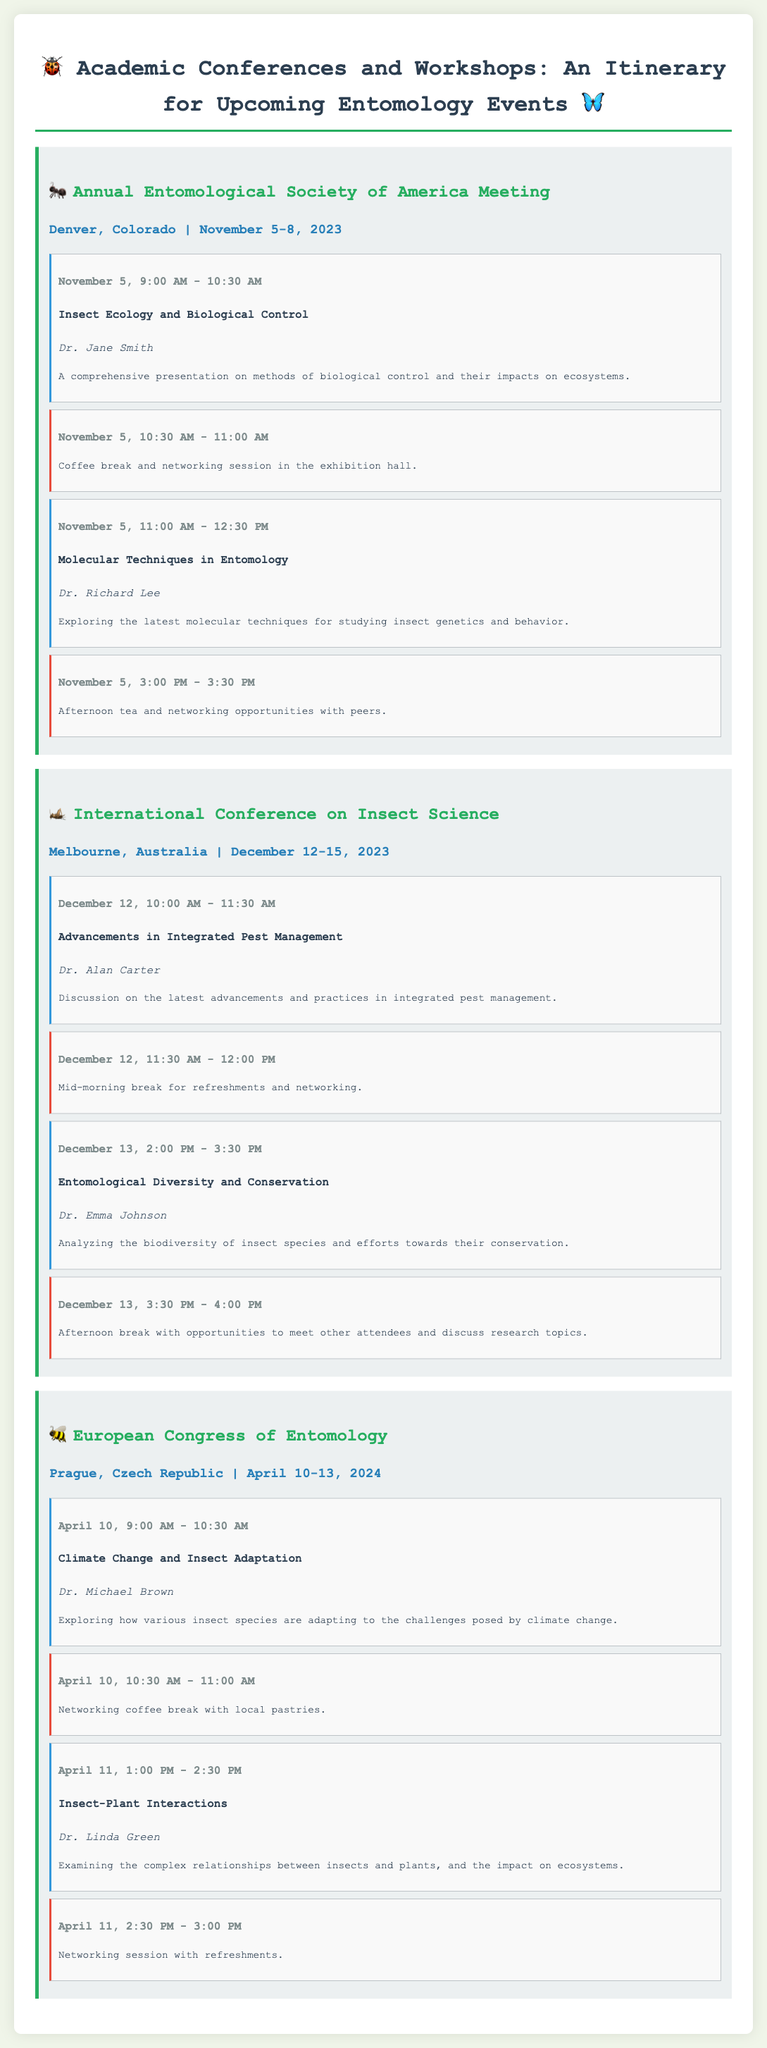what is the location of the Annual Entomological Society of America Meeting? The location is stated in the event header, which is Denver, Colorado.
Answer: Denver, Colorado who is presenting on Insect Ecology and Biological Control? The presenter's name is provided in the presentation section for the topic.
Answer: Dr. Jane Smith what date does the International Conference on Insect Science start? The start date is clearly stated in the event header.
Answer: December 12, 2023 what is the time for the networking coffee break on April 10? The time is listed under the break section for the event on that date.
Answer: 10:30 AM - 11:00 AM how long is the presentation on Climate Change and Insect Adaptation? The duration can be found in the presentation section specifying the start and end times.
Answer: 1.5 hours what is the main focus of Dr. Alan Carter's presentation? The focus is described in the presentation description under his section.
Answer: Integrated Pest Management how many presentations are scheduled on December 13? The number can be counted from the presentation sections specifically labeled for that date.
Answer: 2 what is the overall purpose of this document? The purpose is implied by the title and content focusing on academic events related to entomology.
Answer: Itinerary for Upcoming Entomology Events 